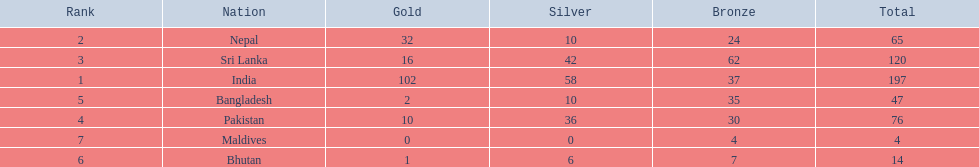What are the totals of medals one in each country? 197, 65, 120, 76, 47, 14, 4. Which of these totals are less than 10? 4. Who won this number of medals? Maldives. 